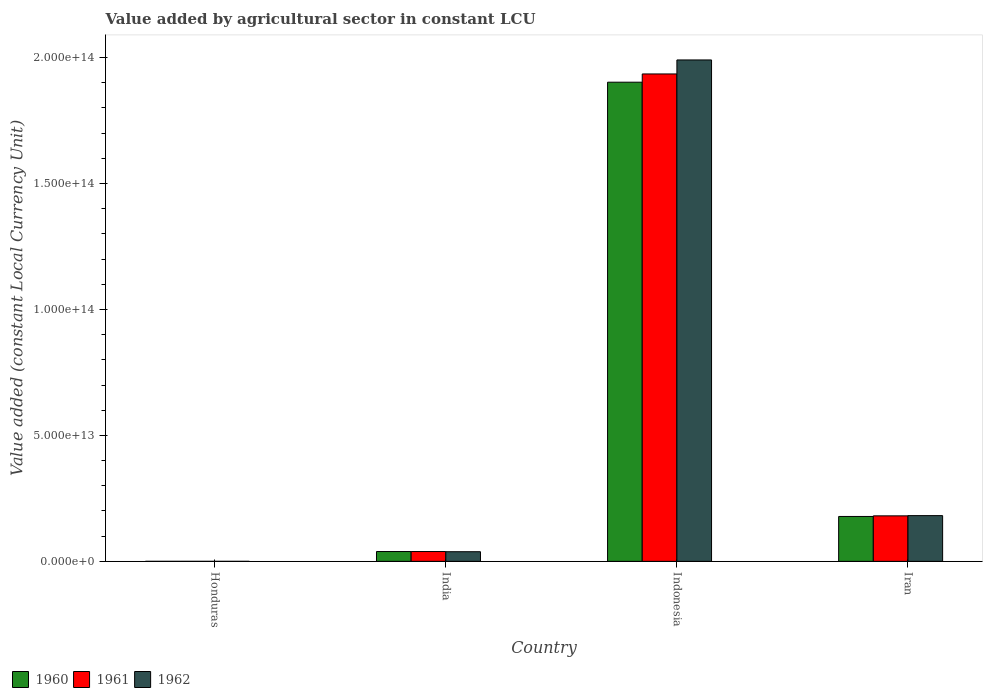How many different coloured bars are there?
Your response must be concise. 3. How many groups of bars are there?
Provide a short and direct response. 4. Are the number of bars per tick equal to the number of legend labels?
Your answer should be very brief. Yes. How many bars are there on the 1st tick from the right?
Your answer should be compact. 3. What is the value added by agricultural sector in 1960 in Iran?
Keep it short and to the point. 1.78e+13. Across all countries, what is the maximum value added by agricultural sector in 1962?
Offer a very short reply. 1.99e+14. Across all countries, what is the minimum value added by agricultural sector in 1961?
Offer a very short reply. 4.73e+09. In which country was the value added by agricultural sector in 1962 minimum?
Your response must be concise. Honduras. What is the total value added by agricultural sector in 1961 in the graph?
Provide a succinct answer. 2.15e+14. What is the difference between the value added by agricultural sector in 1962 in India and that in Indonesia?
Offer a terse response. -1.95e+14. What is the difference between the value added by agricultural sector in 1960 in Indonesia and the value added by agricultural sector in 1962 in Iran?
Your answer should be compact. 1.72e+14. What is the average value added by agricultural sector in 1961 per country?
Make the answer very short. 5.39e+13. What is the difference between the value added by agricultural sector of/in 1962 and value added by agricultural sector of/in 1961 in Honduras?
Offer a very short reply. 2.25e+08. In how many countries, is the value added by agricultural sector in 1962 greater than 70000000000000 LCU?
Your response must be concise. 1. What is the ratio of the value added by agricultural sector in 1961 in Honduras to that in Iran?
Make the answer very short. 0. Is the value added by agricultural sector in 1962 in Honduras less than that in India?
Make the answer very short. Yes. Is the difference between the value added by agricultural sector in 1962 in India and Indonesia greater than the difference between the value added by agricultural sector in 1961 in India and Indonesia?
Your response must be concise. No. What is the difference between the highest and the second highest value added by agricultural sector in 1961?
Give a very brief answer. 1.90e+14. What is the difference between the highest and the lowest value added by agricultural sector in 1962?
Your answer should be very brief. 1.99e+14. In how many countries, is the value added by agricultural sector in 1962 greater than the average value added by agricultural sector in 1962 taken over all countries?
Your answer should be very brief. 1. How many bars are there?
Make the answer very short. 12. How many countries are there in the graph?
Keep it short and to the point. 4. What is the difference between two consecutive major ticks on the Y-axis?
Your answer should be compact. 5.00e+13. Are the values on the major ticks of Y-axis written in scientific E-notation?
Keep it short and to the point. Yes. Does the graph contain grids?
Your answer should be compact. No. Where does the legend appear in the graph?
Offer a very short reply. Bottom left. How are the legend labels stacked?
Your answer should be very brief. Horizontal. What is the title of the graph?
Your response must be concise. Value added by agricultural sector in constant LCU. Does "2010" appear as one of the legend labels in the graph?
Offer a terse response. No. What is the label or title of the X-axis?
Provide a succinct answer. Country. What is the label or title of the Y-axis?
Offer a terse response. Value added (constant Local Currency Unit). What is the Value added (constant Local Currency Unit) of 1960 in Honduras?
Make the answer very short. 4.44e+09. What is the Value added (constant Local Currency Unit) in 1961 in Honduras?
Offer a terse response. 4.73e+09. What is the Value added (constant Local Currency Unit) in 1962 in Honduras?
Make the answer very short. 4.96e+09. What is the Value added (constant Local Currency Unit) of 1960 in India?
Your answer should be very brief. 3.90e+12. What is the Value added (constant Local Currency Unit) in 1961 in India?
Keep it short and to the point. 3.91e+12. What is the Value added (constant Local Currency Unit) of 1962 in India?
Provide a short and direct response. 3.83e+12. What is the Value added (constant Local Currency Unit) of 1960 in Indonesia?
Make the answer very short. 1.90e+14. What is the Value added (constant Local Currency Unit) of 1961 in Indonesia?
Your answer should be compact. 1.94e+14. What is the Value added (constant Local Currency Unit) of 1962 in Indonesia?
Give a very brief answer. 1.99e+14. What is the Value added (constant Local Currency Unit) in 1960 in Iran?
Offer a very short reply. 1.78e+13. What is the Value added (constant Local Currency Unit) of 1961 in Iran?
Provide a short and direct response. 1.81e+13. What is the Value added (constant Local Currency Unit) in 1962 in Iran?
Offer a terse response. 1.82e+13. Across all countries, what is the maximum Value added (constant Local Currency Unit) in 1960?
Your response must be concise. 1.90e+14. Across all countries, what is the maximum Value added (constant Local Currency Unit) of 1961?
Ensure brevity in your answer.  1.94e+14. Across all countries, what is the maximum Value added (constant Local Currency Unit) in 1962?
Give a very brief answer. 1.99e+14. Across all countries, what is the minimum Value added (constant Local Currency Unit) of 1960?
Your response must be concise. 4.44e+09. Across all countries, what is the minimum Value added (constant Local Currency Unit) in 1961?
Provide a short and direct response. 4.73e+09. Across all countries, what is the minimum Value added (constant Local Currency Unit) of 1962?
Make the answer very short. 4.96e+09. What is the total Value added (constant Local Currency Unit) in 1960 in the graph?
Your response must be concise. 2.12e+14. What is the total Value added (constant Local Currency Unit) in 1961 in the graph?
Make the answer very short. 2.15e+14. What is the total Value added (constant Local Currency Unit) in 1962 in the graph?
Your answer should be compact. 2.21e+14. What is the difference between the Value added (constant Local Currency Unit) in 1960 in Honduras and that in India?
Offer a terse response. -3.90e+12. What is the difference between the Value added (constant Local Currency Unit) of 1961 in Honduras and that in India?
Your response must be concise. -3.90e+12. What is the difference between the Value added (constant Local Currency Unit) in 1962 in Honduras and that in India?
Keep it short and to the point. -3.82e+12. What is the difference between the Value added (constant Local Currency Unit) in 1960 in Honduras and that in Indonesia?
Make the answer very short. -1.90e+14. What is the difference between the Value added (constant Local Currency Unit) in 1961 in Honduras and that in Indonesia?
Your response must be concise. -1.94e+14. What is the difference between the Value added (constant Local Currency Unit) of 1962 in Honduras and that in Indonesia?
Offer a very short reply. -1.99e+14. What is the difference between the Value added (constant Local Currency Unit) of 1960 in Honduras and that in Iran?
Ensure brevity in your answer.  -1.78e+13. What is the difference between the Value added (constant Local Currency Unit) in 1961 in Honduras and that in Iran?
Make the answer very short. -1.81e+13. What is the difference between the Value added (constant Local Currency Unit) of 1962 in Honduras and that in Iran?
Give a very brief answer. -1.82e+13. What is the difference between the Value added (constant Local Currency Unit) in 1960 in India and that in Indonesia?
Your response must be concise. -1.86e+14. What is the difference between the Value added (constant Local Currency Unit) in 1961 in India and that in Indonesia?
Provide a short and direct response. -1.90e+14. What is the difference between the Value added (constant Local Currency Unit) in 1962 in India and that in Indonesia?
Offer a terse response. -1.95e+14. What is the difference between the Value added (constant Local Currency Unit) of 1960 in India and that in Iran?
Provide a succinct answer. -1.39e+13. What is the difference between the Value added (constant Local Currency Unit) of 1961 in India and that in Iran?
Ensure brevity in your answer.  -1.42e+13. What is the difference between the Value added (constant Local Currency Unit) in 1962 in India and that in Iran?
Give a very brief answer. -1.43e+13. What is the difference between the Value added (constant Local Currency Unit) in 1960 in Indonesia and that in Iran?
Your answer should be compact. 1.72e+14. What is the difference between the Value added (constant Local Currency Unit) of 1961 in Indonesia and that in Iran?
Provide a short and direct response. 1.75e+14. What is the difference between the Value added (constant Local Currency Unit) in 1962 in Indonesia and that in Iran?
Your answer should be compact. 1.81e+14. What is the difference between the Value added (constant Local Currency Unit) in 1960 in Honduras and the Value added (constant Local Currency Unit) in 1961 in India?
Keep it short and to the point. -3.90e+12. What is the difference between the Value added (constant Local Currency Unit) of 1960 in Honduras and the Value added (constant Local Currency Unit) of 1962 in India?
Your answer should be compact. -3.83e+12. What is the difference between the Value added (constant Local Currency Unit) in 1961 in Honduras and the Value added (constant Local Currency Unit) in 1962 in India?
Ensure brevity in your answer.  -3.83e+12. What is the difference between the Value added (constant Local Currency Unit) in 1960 in Honduras and the Value added (constant Local Currency Unit) in 1961 in Indonesia?
Give a very brief answer. -1.94e+14. What is the difference between the Value added (constant Local Currency Unit) of 1960 in Honduras and the Value added (constant Local Currency Unit) of 1962 in Indonesia?
Offer a very short reply. -1.99e+14. What is the difference between the Value added (constant Local Currency Unit) of 1961 in Honduras and the Value added (constant Local Currency Unit) of 1962 in Indonesia?
Ensure brevity in your answer.  -1.99e+14. What is the difference between the Value added (constant Local Currency Unit) in 1960 in Honduras and the Value added (constant Local Currency Unit) in 1961 in Iran?
Your response must be concise. -1.81e+13. What is the difference between the Value added (constant Local Currency Unit) in 1960 in Honduras and the Value added (constant Local Currency Unit) in 1962 in Iran?
Your response must be concise. -1.82e+13. What is the difference between the Value added (constant Local Currency Unit) of 1961 in Honduras and the Value added (constant Local Currency Unit) of 1962 in Iran?
Make the answer very short. -1.82e+13. What is the difference between the Value added (constant Local Currency Unit) of 1960 in India and the Value added (constant Local Currency Unit) of 1961 in Indonesia?
Provide a short and direct response. -1.90e+14. What is the difference between the Value added (constant Local Currency Unit) in 1960 in India and the Value added (constant Local Currency Unit) in 1962 in Indonesia?
Provide a succinct answer. -1.95e+14. What is the difference between the Value added (constant Local Currency Unit) of 1961 in India and the Value added (constant Local Currency Unit) of 1962 in Indonesia?
Give a very brief answer. -1.95e+14. What is the difference between the Value added (constant Local Currency Unit) of 1960 in India and the Value added (constant Local Currency Unit) of 1961 in Iran?
Provide a short and direct response. -1.42e+13. What is the difference between the Value added (constant Local Currency Unit) of 1960 in India and the Value added (constant Local Currency Unit) of 1962 in Iran?
Provide a succinct answer. -1.43e+13. What is the difference between the Value added (constant Local Currency Unit) of 1961 in India and the Value added (constant Local Currency Unit) of 1962 in Iran?
Make the answer very short. -1.43e+13. What is the difference between the Value added (constant Local Currency Unit) of 1960 in Indonesia and the Value added (constant Local Currency Unit) of 1961 in Iran?
Provide a succinct answer. 1.72e+14. What is the difference between the Value added (constant Local Currency Unit) of 1960 in Indonesia and the Value added (constant Local Currency Unit) of 1962 in Iran?
Your answer should be compact. 1.72e+14. What is the difference between the Value added (constant Local Currency Unit) of 1961 in Indonesia and the Value added (constant Local Currency Unit) of 1962 in Iran?
Provide a short and direct response. 1.75e+14. What is the average Value added (constant Local Currency Unit) of 1960 per country?
Offer a very short reply. 5.30e+13. What is the average Value added (constant Local Currency Unit) of 1961 per country?
Your answer should be very brief. 5.39e+13. What is the average Value added (constant Local Currency Unit) of 1962 per country?
Give a very brief answer. 5.53e+13. What is the difference between the Value added (constant Local Currency Unit) in 1960 and Value added (constant Local Currency Unit) in 1961 in Honduras?
Offer a terse response. -2.90e+08. What is the difference between the Value added (constant Local Currency Unit) of 1960 and Value added (constant Local Currency Unit) of 1962 in Honduras?
Keep it short and to the point. -5.15e+08. What is the difference between the Value added (constant Local Currency Unit) of 1961 and Value added (constant Local Currency Unit) of 1962 in Honduras?
Your response must be concise. -2.25e+08. What is the difference between the Value added (constant Local Currency Unit) of 1960 and Value added (constant Local Currency Unit) of 1961 in India?
Your answer should be compact. -3.29e+09. What is the difference between the Value added (constant Local Currency Unit) in 1960 and Value added (constant Local Currency Unit) in 1962 in India?
Your answer should be compact. 7.44e+1. What is the difference between the Value added (constant Local Currency Unit) of 1961 and Value added (constant Local Currency Unit) of 1962 in India?
Offer a very short reply. 7.77e+1. What is the difference between the Value added (constant Local Currency Unit) in 1960 and Value added (constant Local Currency Unit) in 1961 in Indonesia?
Offer a terse response. -3.27e+12. What is the difference between the Value added (constant Local Currency Unit) of 1960 and Value added (constant Local Currency Unit) of 1962 in Indonesia?
Provide a succinct answer. -8.83e+12. What is the difference between the Value added (constant Local Currency Unit) of 1961 and Value added (constant Local Currency Unit) of 1962 in Indonesia?
Provide a short and direct response. -5.56e+12. What is the difference between the Value added (constant Local Currency Unit) in 1960 and Value added (constant Local Currency Unit) in 1961 in Iran?
Provide a succinct answer. -2.42e+11. What is the difference between the Value added (constant Local Currency Unit) in 1960 and Value added (constant Local Currency Unit) in 1962 in Iran?
Provide a succinct answer. -3.32e+11. What is the difference between the Value added (constant Local Currency Unit) of 1961 and Value added (constant Local Currency Unit) of 1962 in Iran?
Make the answer very short. -8.95e+1. What is the ratio of the Value added (constant Local Currency Unit) in 1960 in Honduras to that in India?
Give a very brief answer. 0. What is the ratio of the Value added (constant Local Currency Unit) of 1961 in Honduras to that in India?
Your response must be concise. 0. What is the ratio of the Value added (constant Local Currency Unit) in 1962 in Honduras to that in India?
Your answer should be very brief. 0. What is the ratio of the Value added (constant Local Currency Unit) of 1961 in Honduras to that in Indonesia?
Provide a short and direct response. 0. What is the ratio of the Value added (constant Local Currency Unit) of 1960 in Honduras to that in Iran?
Your answer should be compact. 0. What is the ratio of the Value added (constant Local Currency Unit) in 1962 in Honduras to that in Iran?
Your answer should be very brief. 0. What is the ratio of the Value added (constant Local Currency Unit) of 1960 in India to that in Indonesia?
Give a very brief answer. 0.02. What is the ratio of the Value added (constant Local Currency Unit) in 1961 in India to that in Indonesia?
Your answer should be very brief. 0.02. What is the ratio of the Value added (constant Local Currency Unit) in 1962 in India to that in Indonesia?
Provide a succinct answer. 0.02. What is the ratio of the Value added (constant Local Currency Unit) in 1960 in India to that in Iran?
Ensure brevity in your answer.  0.22. What is the ratio of the Value added (constant Local Currency Unit) in 1961 in India to that in Iran?
Keep it short and to the point. 0.22. What is the ratio of the Value added (constant Local Currency Unit) in 1962 in India to that in Iran?
Give a very brief answer. 0.21. What is the ratio of the Value added (constant Local Currency Unit) of 1960 in Indonesia to that in Iran?
Provide a succinct answer. 10.67. What is the ratio of the Value added (constant Local Currency Unit) of 1961 in Indonesia to that in Iran?
Provide a short and direct response. 10.71. What is the ratio of the Value added (constant Local Currency Unit) of 1962 in Indonesia to that in Iran?
Provide a succinct answer. 10.96. What is the difference between the highest and the second highest Value added (constant Local Currency Unit) of 1960?
Provide a succinct answer. 1.72e+14. What is the difference between the highest and the second highest Value added (constant Local Currency Unit) in 1961?
Your answer should be compact. 1.75e+14. What is the difference between the highest and the second highest Value added (constant Local Currency Unit) of 1962?
Offer a terse response. 1.81e+14. What is the difference between the highest and the lowest Value added (constant Local Currency Unit) of 1960?
Provide a short and direct response. 1.90e+14. What is the difference between the highest and the lowest Value added (constant Local Currency Unit) of 1961?
Provide a short and direct response. 1.94e+14. What is the difference between the highest and the lowest Value added (constant Local Currency Unit) of 1962?
Your answer should be compact. 1.99e+14. 